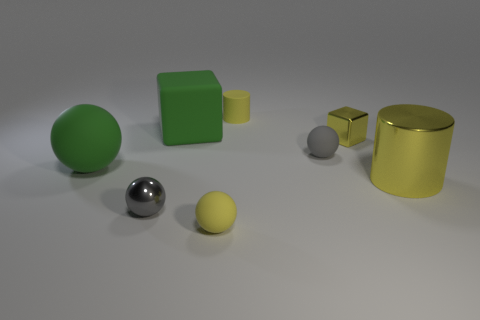Add 2 tiny metal things. How many objects exist? 10 Subtract all blocks. How many objects are left? 6 Add 3 big green objects. How many big green objects are left? 5 Add 8 big yellow metal objects. How many big yellow metal objects exist? 9 Subtract 0 brown cylinders. How many objects are left? 8 Subtract all shiny cylinders. Subtract all metallic things. How many objects are left? 4 